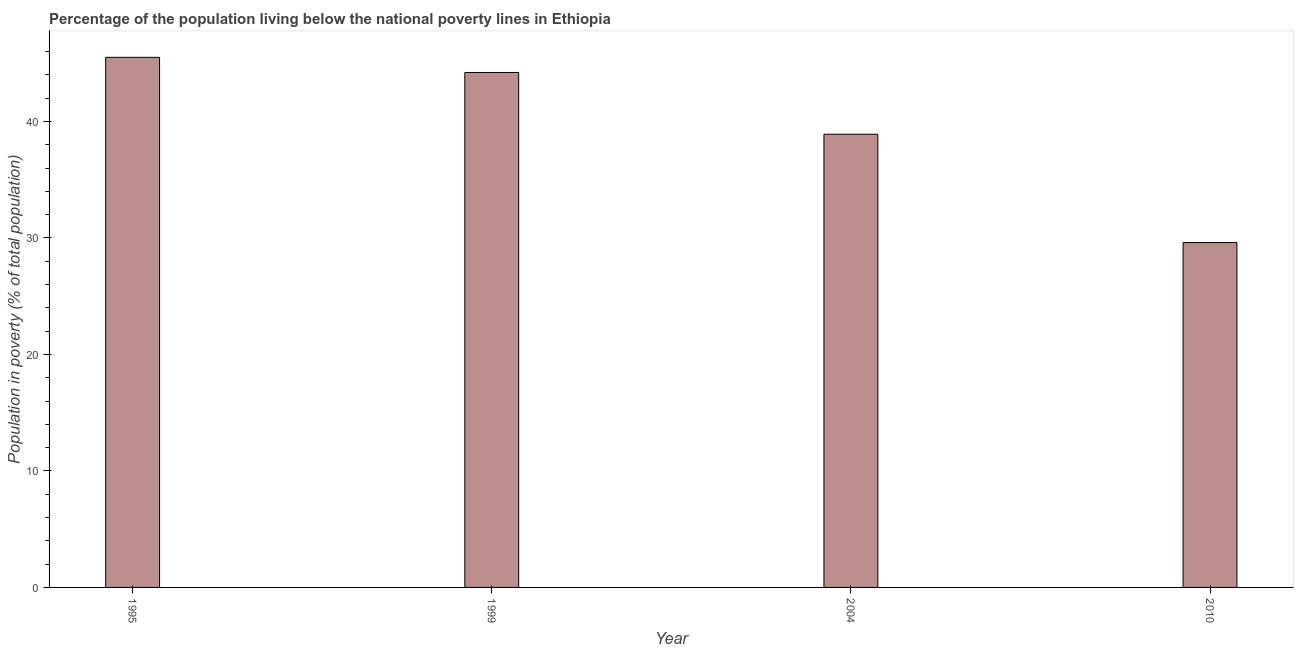Does the graph contain grids?
Provide a succinct answer. No. What is the title of the graph?
Provide a short and direct response. Percentage of the population living below the national poverty lines in Ethiopia. What is the label or title of the X-axis?
Your answer should be very brief. Year. What is the label or title of the Y-axis?
Your answer should be very brief. Population in poverty (% of total population). What is the percentage of population living below poverty line in 2010?
Offer a terse response. 29.6. Across all years, what is the maximum percentage of population living below poverty line?
Your answer should be very brief. 45.5. Across all years, what is the minimum percentage of population living below poverty line?
Offer a terse response. 29.6. In which year was the percentage of population living below poverty line minimum?
Make the answer very short. 2010. What is the sum of the percentage of population living below poverty line?
Offer a terse response. 158.2. What is the average percentage of population living below poverty line per year?
Provide a succinct answer. 39.55. What is the median percentage of population living below poverty line?
Give a very brief answer. 41.55. In how many years, is the percentage of population living below poverty line greater than 22 %?
Offer a terse response. 4. Do a majority of the years between 1999 and 2004 (inclusive) have percentage of population living below poverty line greater than 36 %?
Keep it short and to the point. Yes. What is the ratio of the percentage of population living below poverty line in 1995 to that in 2004?
Your response must be concise. 1.17. Is the difference between the percentage of population living below poverty line in 2004 and 2010 greater than the difference between any two years?
Your answer should be compact. No. What is the difference between the highest and the second highest percentage of population living below poverty line?
Ensure brevity in your answer.  1.3. Is the sum of the percentage of population living below poverty line in 2004 and 2010 greater than the maximum percentage of population living below poverty line across all years?
Make the answer very short. Yes. How many bars are there?
Offer a terse response. 4. Are all the bars in the graph horizontal?
Your response must be concise. No. What is the difference between two consecutive major ticks on the Y-axis?
Offer a terse response. 10. What is the Population in poverty (% of total population) in 1995?
Provide a short and direct response. 45.5. What is the Population in poverty (% of total population) of 1999?
Ensure brevity in your answer.  44.2. What is the Population in poverty (% of total population) of 2004?
Make the answer very short. 38.9. What is the Population in poverty (% of total population) in 2010?
Ensure brevity in your answer.  29.6. What is the difference between the Population in poverty (% of total population) in 1995 and 2004?
Offer a terse response. 6.6. What is the difference between the Population in poverty (% of total population) in 1995 and 2010?
Your answer should be very brief. 15.9. What is the difference between the Population in poverty (% of total population) in 1999 and 2004?
Make the answer very short. 5.3. What is the difference between the Population in poverty (% of total population) in 2004 and 2010?
Offer a very short reply. 9.3. What is the ratio of the Population in poverty (% of total population) in 1995 to that in 2004?
Provide a succinct answer. 1.17. What is the ratio of the Population in poverty (% of total population) in 1995 to that in 2010?
Your answer should be compact. 1.54. What is the ratio of the Population in poverty (% of total population) in 1999 to that in 2004?
Your response must be concise. 1.14. What is the ratio of the Population in poverty (% of total population) in 1999 to that in 2010?
Offer a terse response. 1.49. What is the ratio of the Population in poverty (% of total population) in 2004 to that in 2010?
Provide a short and direct response. 1.31. 